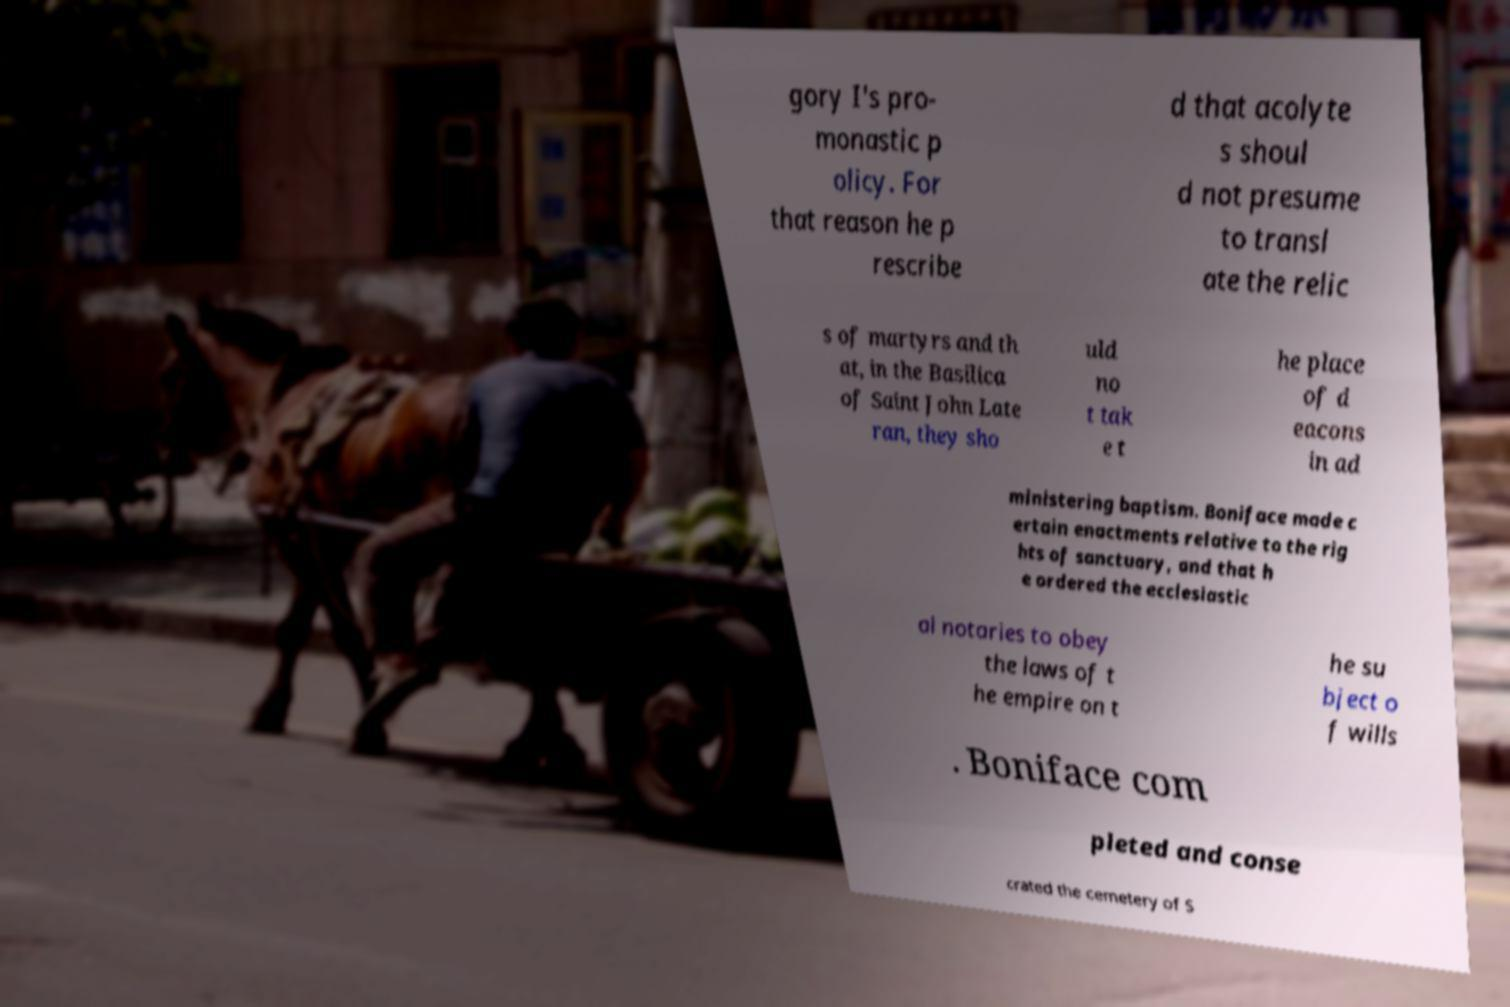Can you accurately transcribe the text from the provided image for me? gory I's pro- monastic p olicy. For that reason he p rescribe d that acolyte s shoul d not presume to transl ate the relic s of martyrs and th at, in the Basilica of Saint John Late ran, they sho uld no t tak e t he place of d eacons in ad ministering baptism. Boniface made c ertain enactments relative to the rig hts of sanctuary, and that h e ordered the ecclesiastic al notaries to obey the laws of t he empire on t he su bject o f wills . Boniface com pleted and conse crated the cemetery of S 